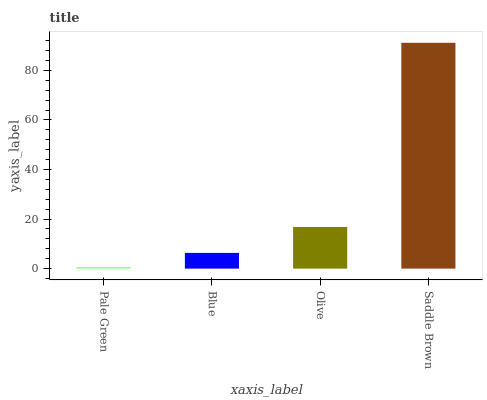Is Blue the minimum?
Answer yes or no. No. Is Blue the maximum?
Answer yes or no. No. Is Blue greater than Pale Green?
Answer yes or no. Yes. Is Pale Green less than Blue?
Answer yes or no. Yes. Is Pale Green greater than Blue?
Answer yes or no. No. Is Blue less than Pale Green?
Answer yes or no. No. Is Olive the high median?
Answer yes or no. Yes. Is Blue the low median?
Answer yes or no. Yes. Is Blue the high median?
Answer yes or no. No. Is Saddle Brown the low median?
Answer yes or no. No. 